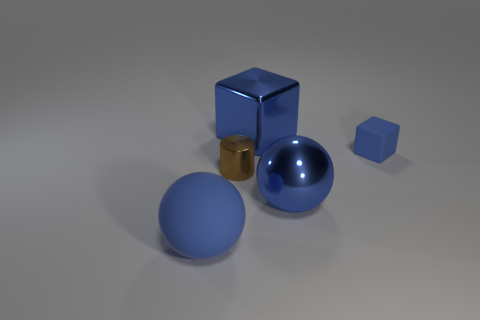How many blue spheres must be subtracted to get 1 blue spheres? 1 Add 3 cyan cylinders. How many objects exist? 8 Subtract 0 green cylinders. How many objects are left? 5 Subtract all cubes. How many objects are left? 3 Subtract 1 balls. How many balls are left? 1 Subtract all red cubes. Subtract all brown cylinders. How many cubes are left? 2 Subtract all tiny metallic things. Subtract all big gray metal things. How many objects are left? 4 Add 3 brown cylinders. How many brown cylinders are left? 4 Add 3 blue metallic balls. How many blue metallic balls exist? 4 